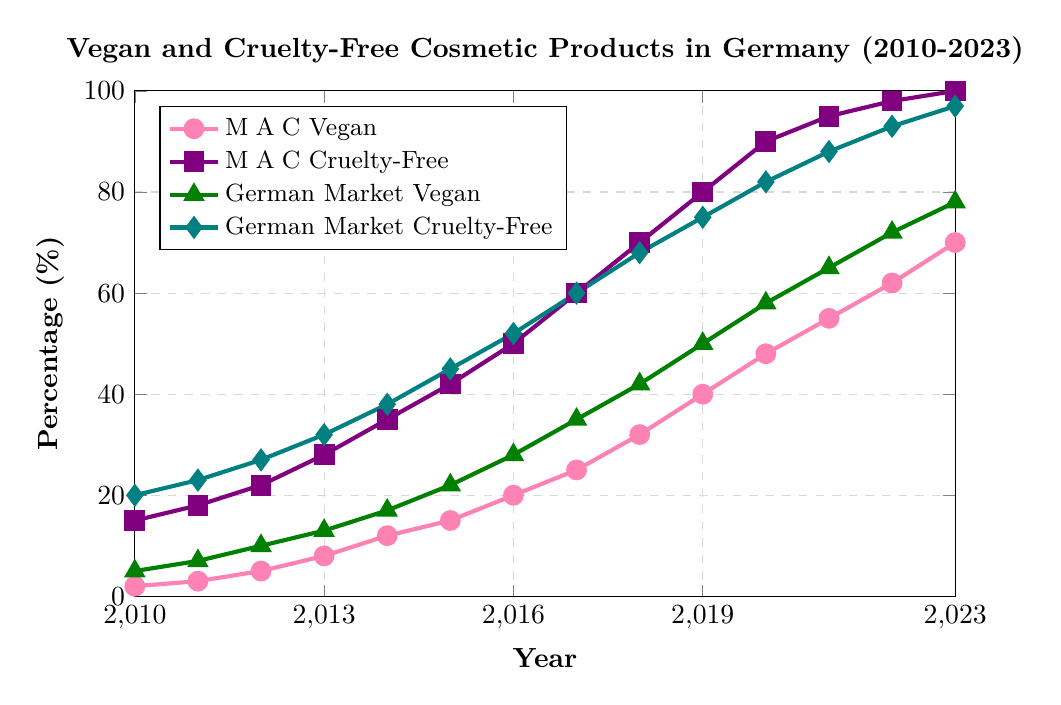Which year did M∙A∙C Cosmetics reach 100% cruelty-free products? The plot shows a line with markers, indicating that M∙A∙C Cosmetics achieved 100% cruelty-free products in the year where the percentage reached 100. This occurred in 2023.
Answer: 2023 How much did the percentage of vegan products for M∙A∙C Cosmetics increase from 2010 to 2023? In 2010, the percentage was 2%, and in 2023, it was 70%. The increase is calculated as 70% - 2% = 68%.
Answer: 68% What is the difference in the percentage of vegan products between the total German market and M∙A∙C Cosmetics in 2015? In 2015, M∙A∙C Cosmetics had 15% vegan products while the total German market had 22%. The difference is 22% - 15% = 7%.
Answer: 7% Between 2010 and 2023, which category showed the highest final percentage increase in the total German market, vegan or cruelty-free products? By observing the final percentages in 2023, vegan products reached 78% and cruelty-free products reached 97%. Cruelty-free products showed the highest final percentage.
Answer: Cruelty-Free Products What is the average yearly increase in M∙A∙C Cosmetics cruelty-free products from 2010 to 2023? The percentage increased from 15% in 2010 to 100% in 2023, which is a 85% total increase over 13 years. The average yearly increase is 85% / 13 ≈ 6.54%.
Answer: 6.54% Did the percentage of cruelty-free products in M∙A∙C Cosmetics ever surpass that of the total German market before 2023? If yes, when? By comparing the annually plotted points, M∙A∙C Cosmetics first surpasses the total German market percentage in 2018, at 70% compared to the market's 68%.
Answer: 2018 In which year did the German market reach 50% vegan products? The plot shows that the total German market reached 50% vegan products in 2019.
Answer: 2019 By how much did the percentage of vegan products in the German market increase between 2020 and 2023? In 2020, the percentage was 58%, and it reached 78% in 2023, leading to an increase of 78% - 58% = 20%.
Answer: 20% Compare the trend lines for M∙A∙C Cosmetics vegan and cruelty-free products. How do their slopes differ? The M∙A∙C cruelty-free line is steeper, indicating a faster increase compared to the less steep slope of the vegan line, which shows a steadier but slower increase.
Answer: Cruelty-Free increased faster What was the percentage of cruelty-free products in the total German market in 2014? The plotted data point for the total German market indicates 38% for cruelty-free products in 2014.
Answer: 38% 